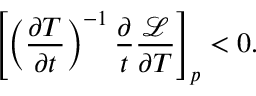Convert formula to latex. <formula><loc_0><loc_0><loc_500><loc_500>\left [ \left ( \frac { \partial T } { \partial t } \right ) ^ { - 1 } \frac { \partial } { t } \frac { \mathcal { L } } { \partial T } \right ] _ { p } < 0 .</formula> 